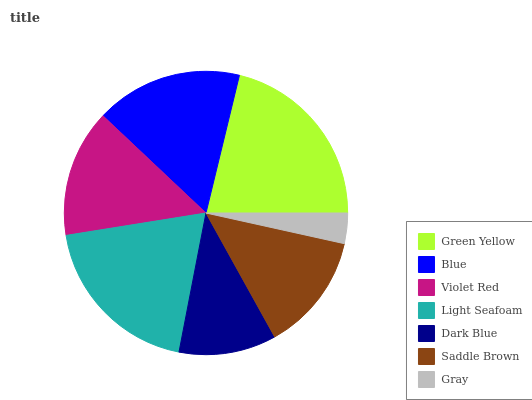Is Gray the minimum?
Answer yes or no. Yes. Is Green Yellow the maximum?
Answer yes or no. Yes. Is Blue the minimum?
Answer yes or no. No. Is Blue the maximum?
Answer yes or no. No. Is Green Yellow greater than Blue?
Answer yes or no. Yes. Is Blue less than Green Yellow?
Answer yes or no. Yes. Is Blue greater than Green Yellow?
Answer yes or no. No. Is Green Yellow less than Blue?
Answer yes or no. No. Is Violet Red the high median?
Answer yes or no. Yes. Is Violet Red the low median?
Answer yes or no. Yes. Is Blue the high median?
Answer yes or no. No. Is Dark Blue the low median?
Answer yes or no. No. 